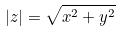<formula> <loc_0><loc_0><loc_500><loc_500>| z | = \sqrt { x ^ { 2 } + y ^ { 2 } }</formula> 